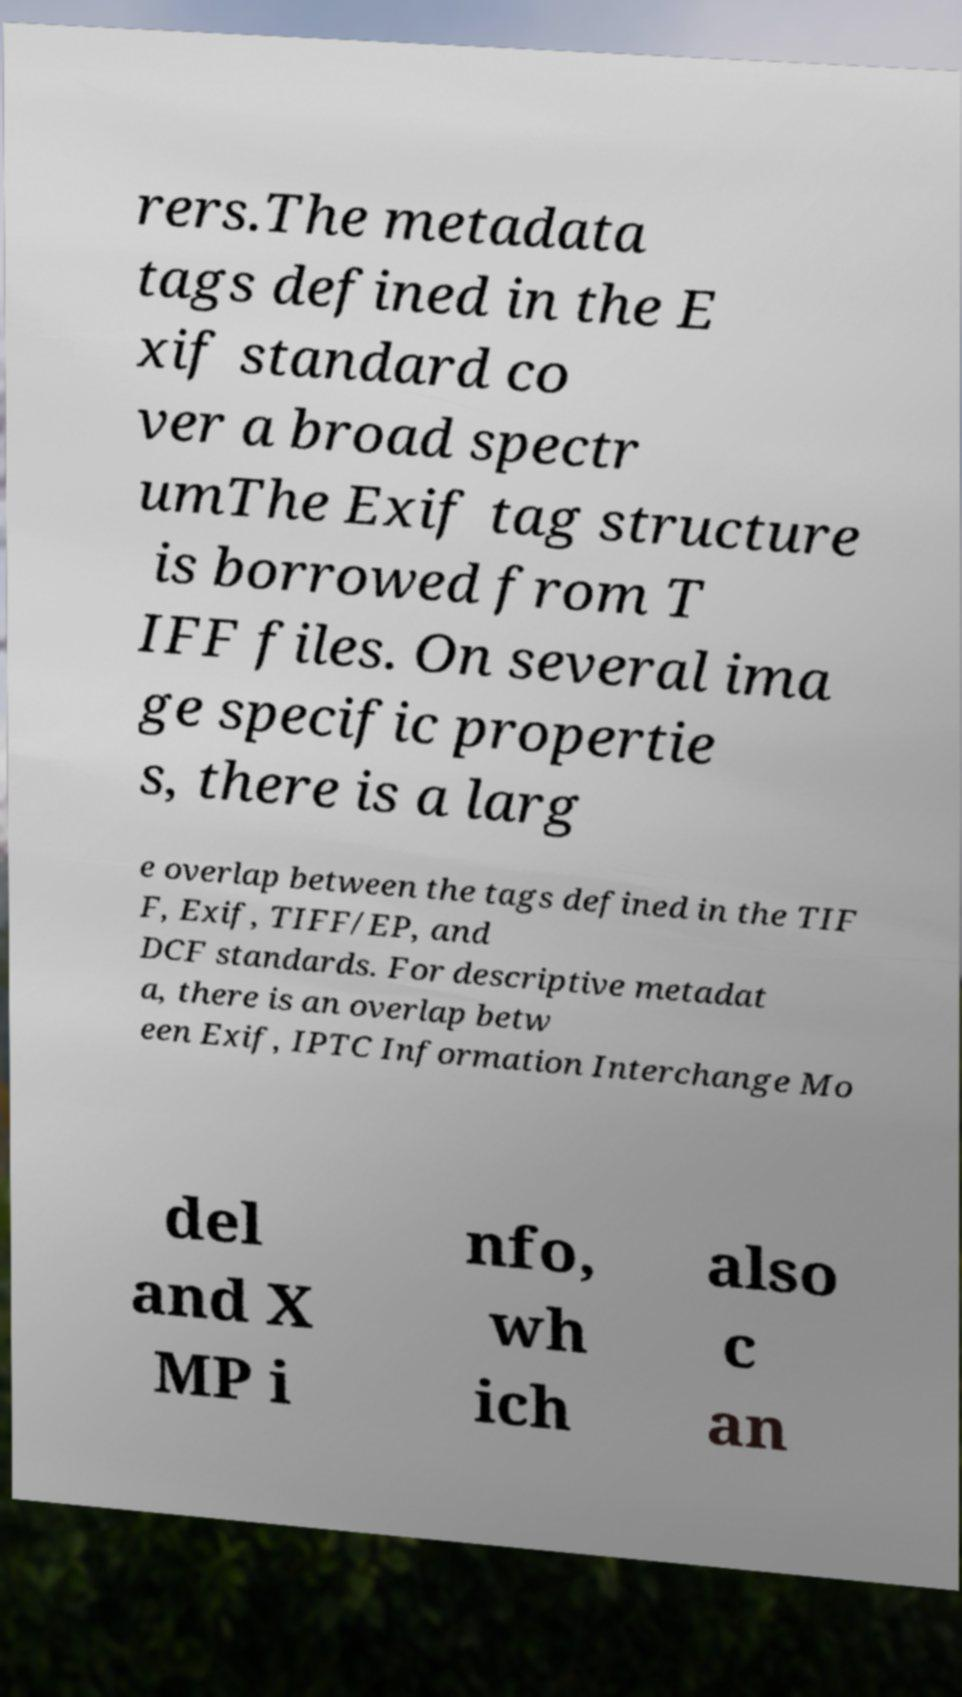I need the written content from this picture converted into text. Can you do that? rers.The metadata tags defined in the E xif standard co ver a broad spectr umThe Exif tag structure is borrowed from T IFF files. On several ima ge specific propertie s, there is a larg e overlap between the tags defined in the TIF F, Exif, TIFF/EP, and DCF standards. For descriptive metadat a, there is an overlap betw een Exif, IPTC Information Interchange Mo del and X MP i nfo, wh ich also c an 